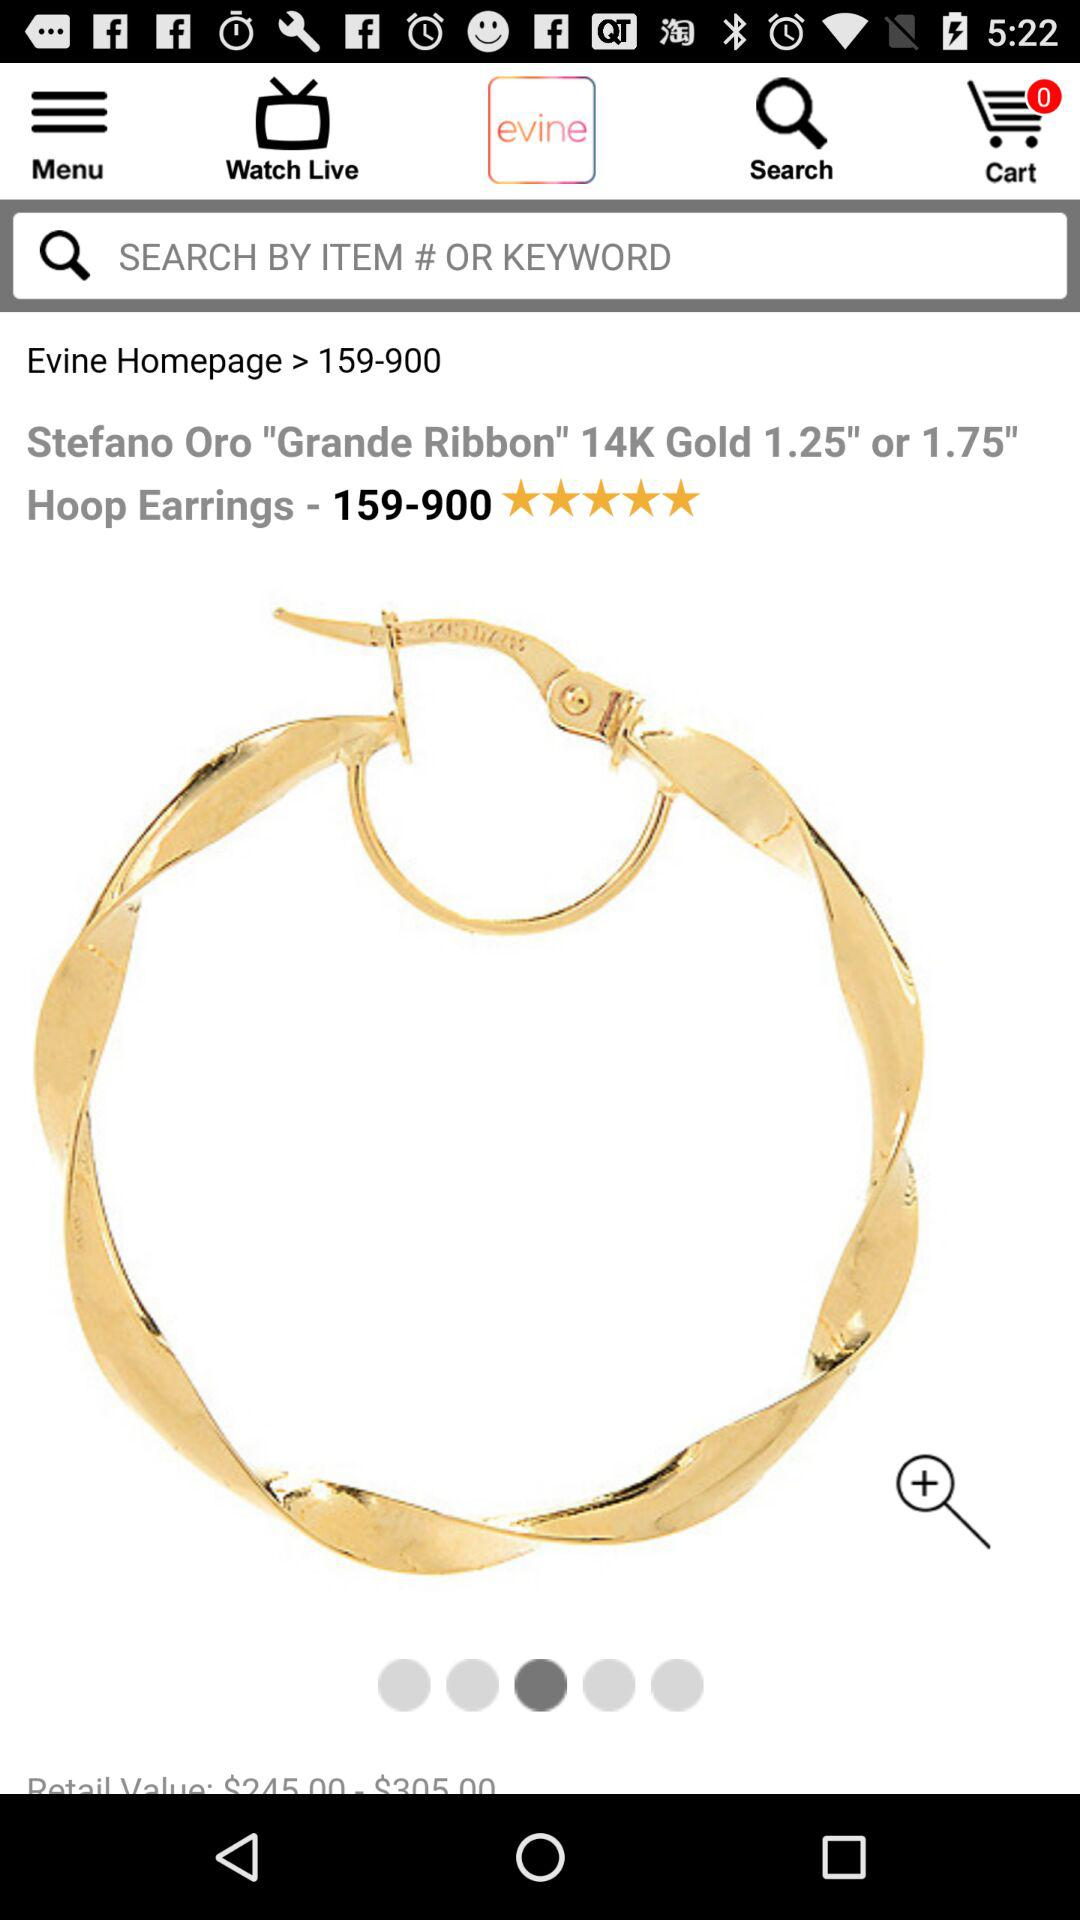What is the price for hoop earrings? The price for hoop earrings ranges from $245.00 to $305.00. 